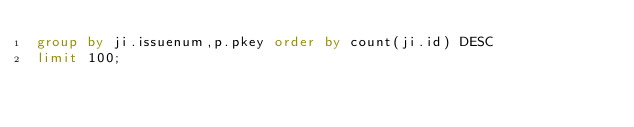<code> <loc_0><loc_0><loc_500><loc_500><_SQL_>group by ji.issuenum,p.pkey order by count(ji.id) DESC
limit 100;</code> 